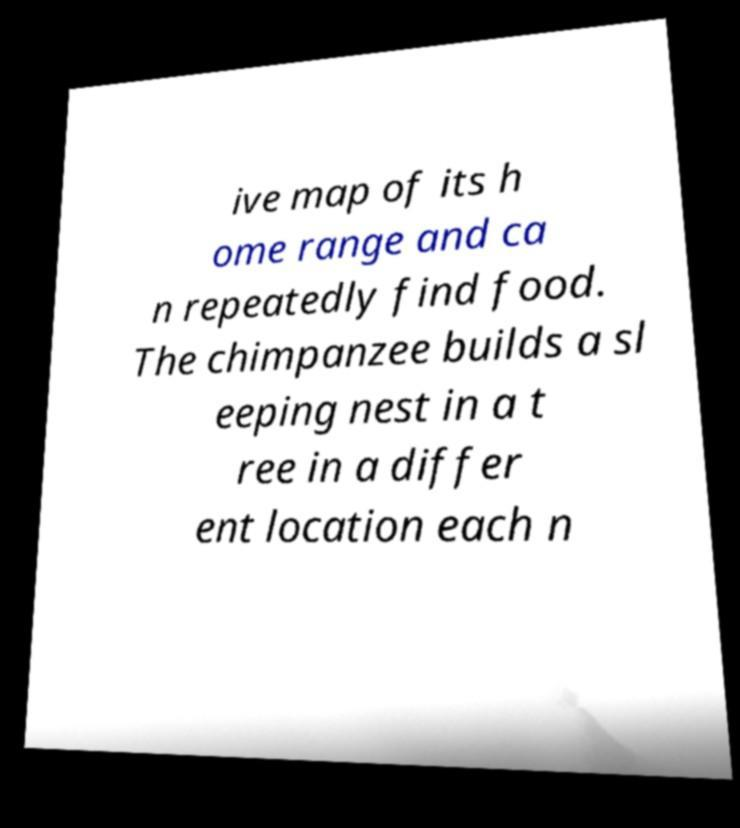For documentation purposes, I need the text within this image transcribed. Could you provide that? ive map of its h ome range and ca n repeatedly find food. The chimpanzee builds a sl eeping nest in a t ree in a differ ent location each n 